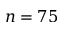Convert formula to latex. <formula><loc_0><loc_0><loc_500><loc_500>n = 7 5</formula> 